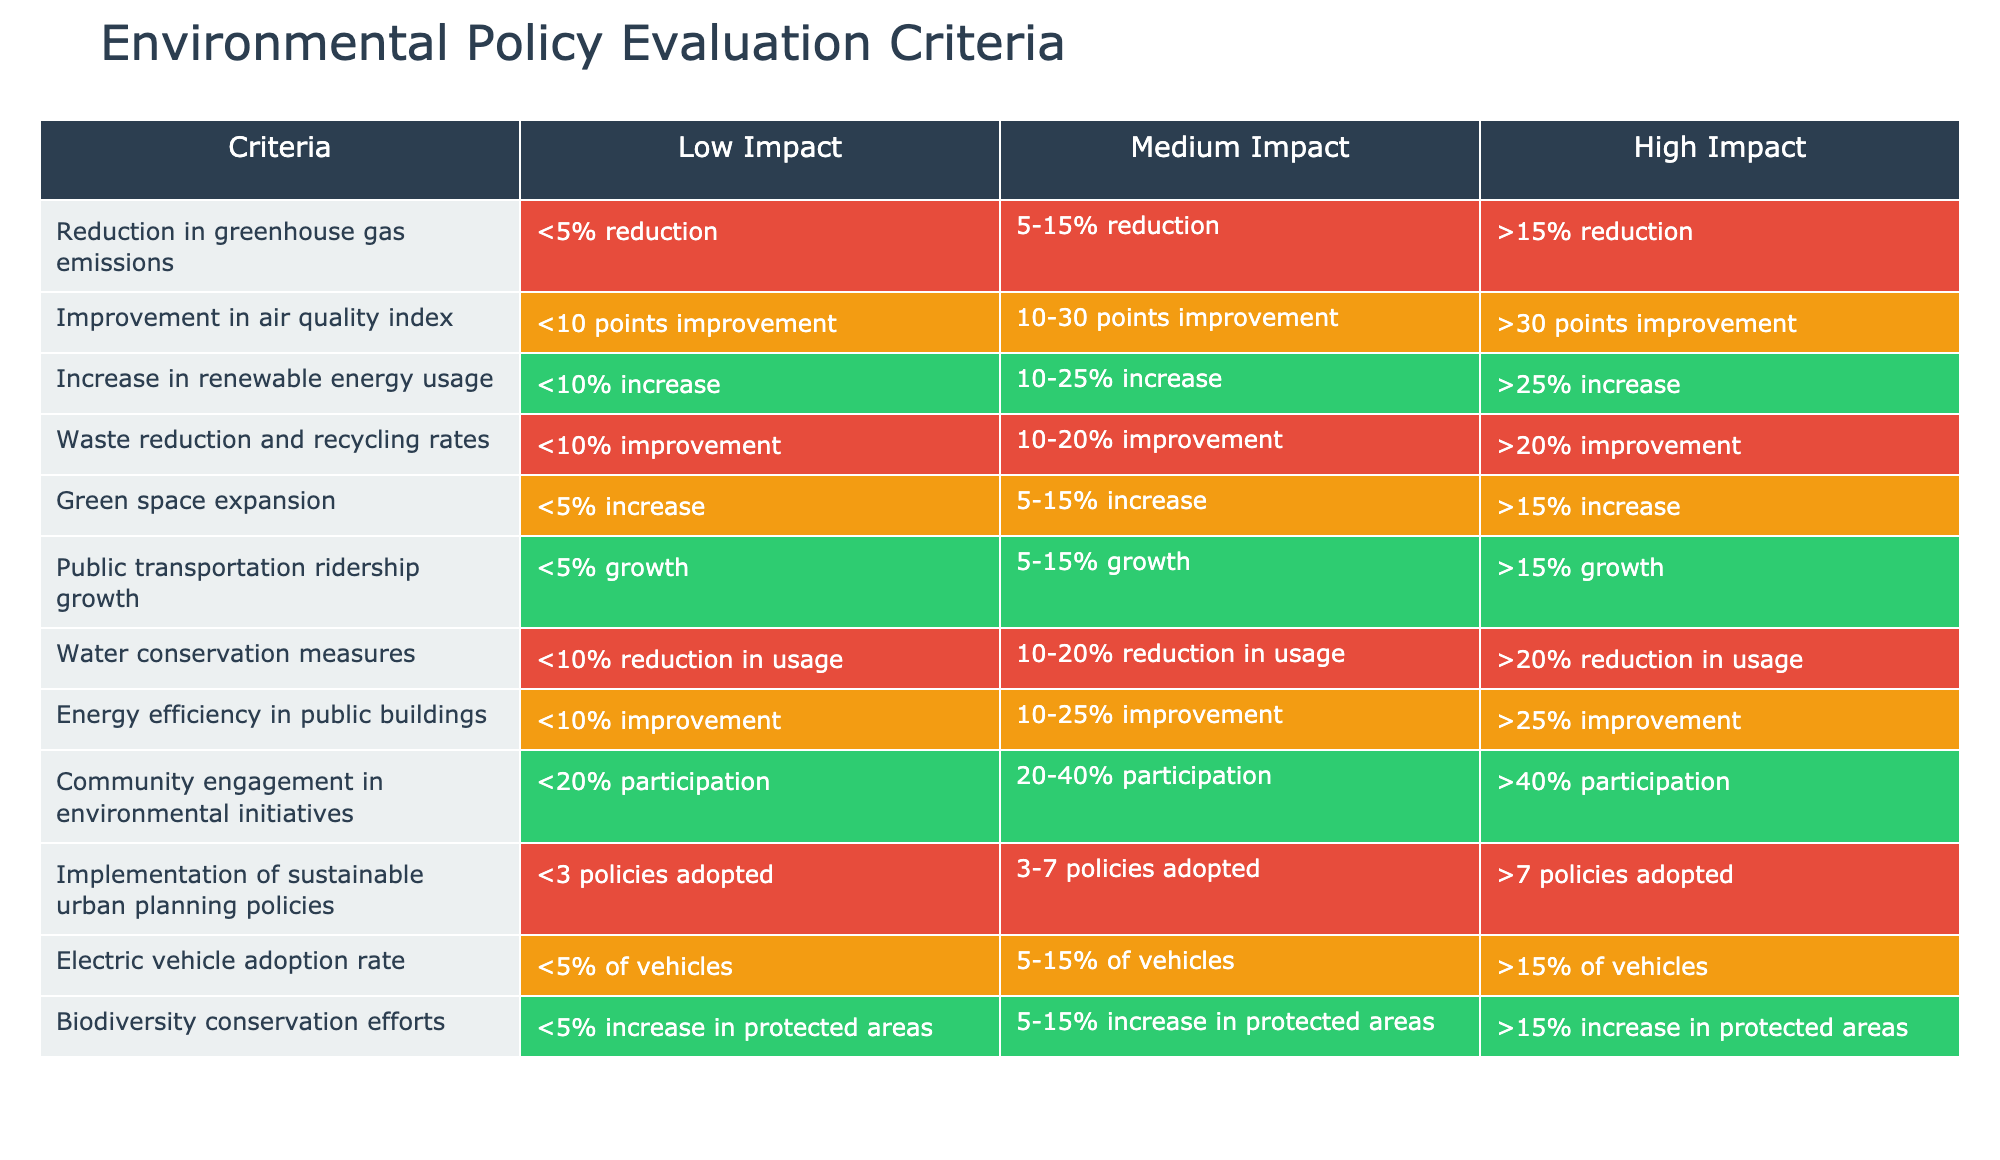What is the impact level for the reduction in greenhouse gas emissions if there is a 12% reduction? A 12% reduction falls between the 5-15% range, which corresponds to a Medium Impact according to the table.
Answer: Medium Impact How much improvement in the air quality index corresponds to a Low Impact? The table indicates that a Low Impact in the air quality index is defined as less than 10 points improvement.
Answer: Less than 10 points improvement Is the increase in renewable energy usage of 15% considered High Impact? Since 15% increase falls within the 10-25% range, which is classified as Medium Impact, it is not considered High Impact.
Answer: No What is the combined categorization of waste reduction and recycling rates that improve by 25%? A 25% improvement falls into the High Impact category according to the table, which specifically states that improvements greater than 20% are classified as High Impact.
Answer: High Impact What is the average improvement in water conservation usage for Low, Medium, and High Impact levels? For Low Impact it is <10%, for Medium it is 10-20%, and for High it is >20%. To average these: (10+20)/2 = 15; therefore, the median level of water conservation corresponds to 15%.
Answer: 15% If a local government expands green space by 10%, what is the impact classification? A 10% increase in green space falls within the 5-15% range, which is categorized as Medium Impact according to the table.
Answer: Medium Impact How many policies need to be adopted to achieve Very High Impact in sustainable urban planning? The table states that adopting more than 7 policies is categorized as High Impact, hence to achieve Very High Impact, local governments would need to adopt more than 7 policies on sustainable urban planning.
Answer: More than 7 policies Does an electric vehicle adoption rate of 4% indicate a High Impact? The table specifies that High Impact is classified as greater than 15%, therefore, an adoption rate of 4% does not indicate High Impact.
Answer: No What is the difference in community engagement participation between Low and High Impact? For Low Impact, it is 20%, and for High Impact, it is >40%. The difference is >40% - 20% = >20%.
Answer: >20% 